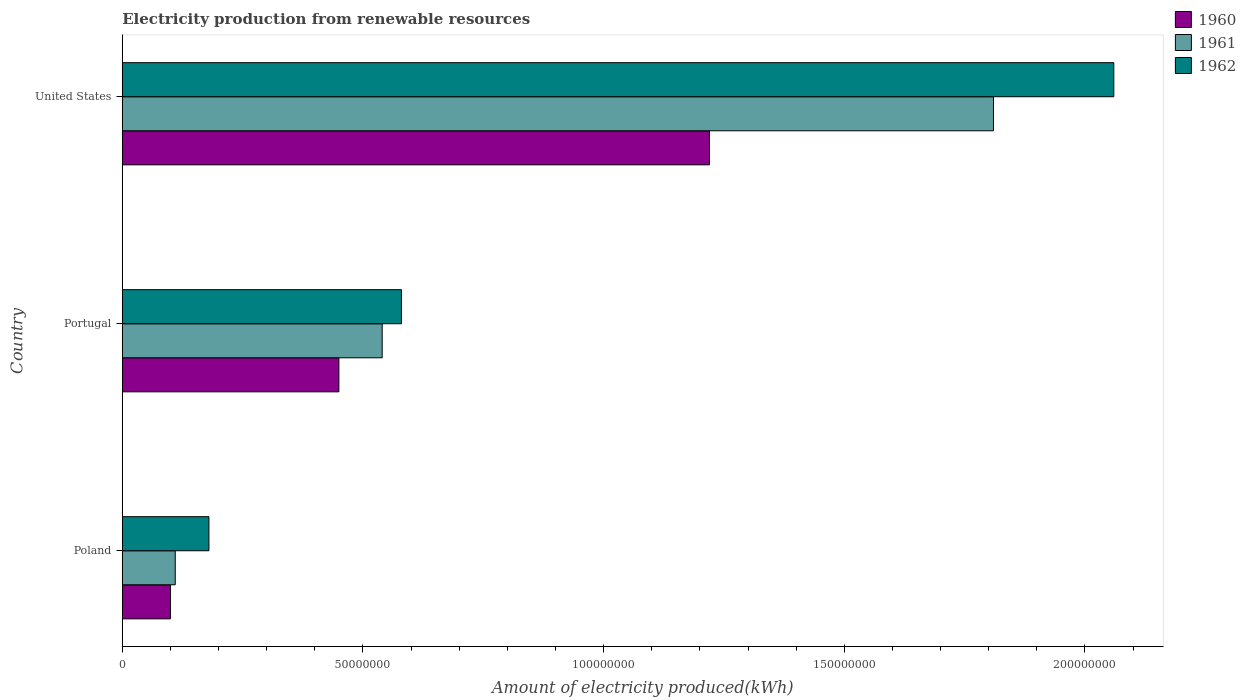How many different coloured bars are there?
Ensure brevity in your answer.  3. How many groups of bars are there?
Offer a terse response. 3. Are the number of bars on each tick of the Y-axis equal?
Your response must be concise. Yes. In how many cases, is the number of bars for a given country not equal to the number of legend labels?
Give a very brief answer. 0. What is the amount of electricity produced in 1960 in United States?
Provide a short and direct response. 1.22e+08. Across all countries, what is the maximum amount of electricity produced in 1960?
Make the answer very short. 1.22e+08. Across all countries, what is the minimum amount of electricity produced in 1961?
Provide a short and direct response. 1.10e+07. In which country was the amount of electricity produced in 1961 maximum?
Your answer should be very brief. United States. In which country was the amount of electricity produced in 1962 minimum?
Make the answer very short. Poland. What is the total amount of electricity produced in 1960 in the graph?
Offer a terse response. 1.77e+08. What is the difference between the amount of electricity produced in 1962 in Poland and that in United States?
Provide a short and direct response. -1.88e+08. What is the difference between the amount of electricity produced in 1961 in Poland and the amount of electricity produced in 1960 in United States?
Provide a succinct answer. -1.11e+08. What is the average amount of electricity produced in 1960 per country?
Offer a very short reply. 5.90e+07. What is the difference between the amount of electricity produced in 1960 and amount of electricity produced in 1961 in Poland?
Your answer should be very brief. -1.00e+06. In how many countries, is the amount of electricity produced in 1961 greater than 100000000 kWh?
Your response must be concise. 1. What is the ratio of the amount of electricity produced in 1962 in Poland to that in Portugal?
Provide a short and direct response. 0.31. Is the amount of electricity produced in 1961 in Portugal less than that in United States?
Provide a short and direct response. Yes. Is the difference between the amount of electricity produced in 1960 in Poland and Portugal greater than the difference between the amount of electricity produced in 1961 in Poland and Portugal?
Keep it short and to the point. Yes. What is the difference between the highest and the second highest amount of electricity produced in 1962?
Offer a very short reply. 1.48e+08. What is the difference between the highest and the lowest amount of electricity produced in 1960?
Provide a short and direct response. 1.12e+08. What is the difference between two consecutive major ticks on the X-axis?
Offer a very short reply. 5.00e+07. Are the values on the major ticks of X-axis written in scientific E-notation?
Keep it short and to the point. No. Does the graph contain any zero values?
Make the answer very short. No. Where does the legend appear in the graph?
Make the answer very short. Top right. What is the title of the graph?
Your answer should be very brief. Electricity production from renewable resources. Does "1995" appear as one of the legend labels in the graph?
Ensure brevity in your answer.  No. What is the label or title of the X-axis?
Your answer should be compact. Amount of electricity produced(kWh). What is the Amount of electricity produced(kWh) of 1960 in Poland?
Ensure brevity in your answer.  1.00e+07. What is the Amount of electricity produced(kWh) in 1961 in Poland?
Provide a succinct answer. 1.10e+07. What is the Amount of electricity produced(kWh) of 1962 in Poland?
Offer a terse response. 1.80e+07. What is the Amount of electricity produced(kWh) of 1960 in Portugal?
Your response must be concise. 4.50e+07. What is the Amount of electricity produced(kWh) in 1961 in Portugal?
Keep it short and to the point. 5.40e+07. What is the Amount of electricity produced(kWh) of 1962 in Portugal?
Make the answer very short. 5.80e+07. What is the Amount of electricity produced(kWh) of 1960 in United States?
Your answer should be compact. 1.22e+08. What is the Amount of electricity produced(kWh) in 1961 in United States?
Offer a very short reply. 1.81e+08. What is the Amount of electricity produced(kWh) in 1962 in United States?
Ensure brevity in your answer.  2.06e+08. Across all countries, what is the maximum Amount of electricity produced(kWh) in 1960?
Offer a terse response. 1.22e+08. Across all countries, what is the maximum Amount of electricity produced(kWh) of 1961?
Provide a short and direct response. 1.81e+08. Across all countries, what is the maximum Amount of electricity produced(kWh) in 1962?
Provide a short and direct response. 2.06e+08. Across all countries, what is the minimum Amount of electricity produced(kWh) in 1961?
Give a very brief answer. 1.10e+07. Across all countries, what is the minimum Amount of electricity produced(kWh) of 1962?
Offer a terse response. 1.80e+07. What is the total Amount of electricity produced(kWh) in 1960 in the graph?
Offer a very short reply. 1.77e+08. What is the total Amount of electricity produced(kWh) in 1961 in the graph?
Make the answer very short. 2.46e+08. What is the total Amount of electricity produced(kWh) in 1962 in the graph?
Offer a very short reply. 2.82e+08. What is the difference between the Amount of electricity produced(kWh) in 1960 in Poland and that in Portugal?
Offer a terse response. -3.50e+07. What is the difference between the Amount of electricity produced(kWh) in 1961 in Poland and that in Portugal?
Offer a terse response. -4.30e+07. What is the difference between the Amount of electricity produced(kWh) of 1962 in Poland and that in Portugal?
Your answer should be compact. -4.00e+07. What is the difference between the Amount of electricity produced(kWh) in 1960 in Poland and that in United States?
Your response must be concise. -1.12e+08. What is the difference between the Amount of electricity produced(kWh) in 1961 in Poland and that in United States?
Make the answer very short. -1.70e+08. What is the difference between the Amount of electricity produced(kWh) of 1962 in Poland and that in United States?
Provide a short and direct response. -1.88e+08. What is the difference between the Amount of electricity produced(kWh) in 1960 in Portugal and that in United States?
Provide a short and direct response. -7.70e+07. What is the difference between the Amount of electricity produced(kWh) in 1961 in Portugal and that in United States?
Make the answer very short. -1.27e+08. What is the difference between the Amount of electricity produced(kWh) in 1962 in Portugal and that in United States?
Give a very brief answer. -1.48e+08. What is the difference between the Amount of electricity produced(kWh) of 1960 in Poland and the Amount of electricity produced(kWh) of 1961 in Portugal?
Keep it short and to the point. -4.40e+07. What is the difference between the Amount of electricity produced(kWh) in 1960 in Poland and the Amount of electricity produced(kWh) in 1962 in Portugal?
Your answer should be compact. -4.80e+07. What is the difference between the Amount of electricity produced(kWh) of 1961 in Poland and the Amount of electricity produced(kWh) of 1962 in Portugal?
Offer a very short reply. -4.70e+07. What is the difference between the Amount of electricity produced(kWh) in 1960 in Poland and the Amount of electricity produced(kWh) in 1961 in United States?
Offer a terse response. -1.71e+08. What is the difference between the Amount of electricity produced(kWh) of 1960 in Poland and the Amount of electricity produced(kWh) of 1962 in United States?
Provide a succinct answer. -1.96e+08. What is the difference between the Amount of electricity produced(kWh) of 1961 in Poland and the Amount of electricity produced(kWh) of 1962 in United States?
Your answer should be compact. -1.95e+08. What is the difference between the Amount of electricity produced(kWh) in 1960 in Portugal and the Amount of electricity produced(kWh) in 1961 in United States?
Your response must be concise. -1.36e+08. What is the difference between the Amount of electricity produced(kWh) in 1960 in Portugal and the Amount of electricity produced(kWh) in 1962 in United States?
Provide a succinct answer. -1.61e+08. What is the difference between the Amount of electricity produced(kWh) of 1961 in Portugal and the Amount of electricity produced(kWh) of 1962 in United States?
Your answer should be compact. -1.52e+08. What is the average Amount of electricity produced(kWh) in 1960 per country?
Your answer should be very brief. 5.90e+07. What is the average Amount of electricity produced(kWh) of 1961 per country?
Ensure brevity in your answer.  8.20e+07. What is the average Amount of electricity produced(kWh) of 1962 per country?
Offer a very short reply. 9.40e+07. What is the difference between the Amount of electricity produced(kWh) in 1960 and Amount of electricity produced(kWh) in 1961 in Poland?
Provide a succinct answer. -1.00e+06. What is the difference between the Amount of electricity produced(kWh) of 1960 and Amount of electricity produced(kWh) of 1962 in Poland?
Your answer should be compact. -8.00e+06. What is the difference between the Amount of electricity produced(kWh) of 1961 and Amount of electricity produced(kWh) of 1962 in Poland?
Keep it short and to the point. -7.00e+06. What is the difference between the Amount of electricity produced(kWh) of 1960 and Amount of electricity produced(kWh) of 1961 in Portugal?
Your answer should be very brief. -9.00e+06. What is the difference between the Amount of electricity produced(kWh) of 1960 and Amount of electricity produced(kWh) of 1962 in Portugal?
Offer a very short reply. -1.30e+07. What is the difference between the Amount of electricity produced(kWh) of 1960 and Amount of electricity produced(kWh) of 1961 in United States?
Your answer should be compact. -5.90e+07. What is the difference between the Amount of electricity produced(kWh) of 1960 and Amount of electricity produced(kWh) of 1962 in United States?
Your response must be concise. -8.40e+07. What is the difference between the Amount of electricity produced(kWh) in 1961 and Amount of electricity produced(kWh) in 1962 in United States?
Provide a succinct answer. -2.50e+07. What is the ratio of the Amount of electricity produced(kWh) in 1960 in Poland to that in Portugal?
Offer a very short reply. 0.22. What is the ratio of the Amount of electricity produced(kWh) in 1961 in Poland to that in Portugal?
Provide a short and direct response. 0.2. What is the ratio of the Amount of electricity produced(kWh) in 1962 in Poland to that in Portugal?
Offer a terse response. 0.31. What is the ratio of the Amount of electricity produced(kWh) of 1960 in Poland to that in United States?
Offer a terse response. 0.08. What is the ratio of the Amount of electricity produced(kWh) in 1961 in Poland to that in United States?
Your response must be concise. 0.06. What is the ratio of the Amount of electricity produced(kWh) in 1962 in Poland to that in United States?
Give a very brief answer. 0.09. What is the ratio of the Amount of electricity produced(kWh) of 1960 in Portugal to that in United States?
Your answer should be very brief. 0.37. What is the ratio of the Amount of electricity produced(kWh) of 1961 in Portugal to that in United States?
Give a very brief answer. 0.3. What is the ratio of the Amount of electricity produced(kWh) of 1962 in Portugal to that in United States?
Provide a succinct answer. 0.28. What is the difference between the highest and the second highest Amount of electricity produced(kWh) of 1960?
Provide a short and direct response. 7.70e+07. What is the difference between the highest and the second highest Amount of electricity produced(kWh) in 1961?
Keep it short and to the point. 1.27e+08. What is the difference between the highest and the second highest Amount of electricity produced(kWh) of 1962?
Make the answer very short. 1.48e+08. What is the difference between the highest and the lowest Amount of electricity produced(kWh) in 1960?
Give a very brief answer. 1.12e+08. What is the difference between the highest and the lowest Amount of electricity produced(kWh) of 1961?
Provide a succinct answer. 1.70e+08. What is the difference between the highest and the lowest Amount of electricity produced(kWh) of 1962?
Your answer should be very brief. 1.88e+08. 